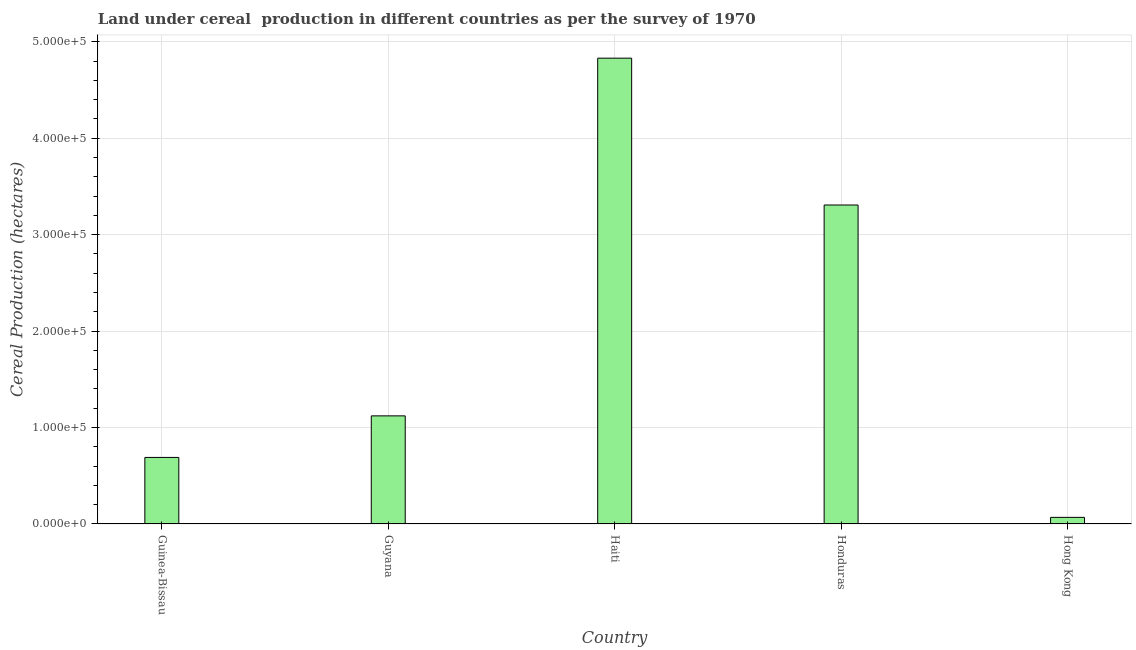Does the graph contain any zero values?
Your answer should be compact. No. What is the title of the graph?
Offer a terse response. Land under cereal  production in different countries as per the survey of 1970. What is the label or title of the X-axis?
Offer a very short reply. Country. What is the label or title of the Y-axis?
Your response must be concise. Cereal Production (hectares). What is the land under cereal production in Guinea-Bissau?
Offer a terse response. 6.90e+04. Across all countries, what is the maximum land under cereal production?
Provide a short and direct response. 4.83e+05. Across all countries, what is the minimum land under cereal production?
Provide a succinct answer. 6861. In which country was the land under cereal production maximum?
Provide a short and direct response. Haiti. In which country was the land under cereal production minimum?
Provide a succinct answer. Hong Kong. What is the sum of the land under cereal production?
Keep it short and to the point. 1.00e+06. What is the difference between the land under cereal production in Guinea-Bissau and Guyana?
Your answer should be compact. -4.31e+04. What is the average land under cereal production per country?
Ensure brevity in your answer.  2.00e+05. What is the median land under cereal production?
Provide a succinct answer. 1.12e+05. In how many countries, is the land under cereal production greater than 260000 hectares?
Offer a very short reply. 2. What is the ratio of the land under cereal production in Guinea-Bissau to that in Honduras?
Provide a short and direct response. 0.21. Is the difference between the land under cereal production in Guyana and Honduras greater than the difference between any two countries?
Give a very brief answer. No. What is the difference between the highest and the second highest land under cereal production?
Provide a short and direct response. 1.52e+05. Is the sum of the land under cereal production in Guyana and Haiti greater than the maximum land under cereal production across all countries?
Provide a short and direct response. Yes. What is the difference between the highest and the lowest land under cereal production?
Make the answer very short. 4.76e+05. How many bars are there?
Ensure brevity in your answer.  5. What is the Cereal Production (hectares) in Guinea-Bissau?
Provide a succinct answer. 6.90e+04. What is the Cereal Production (hectares) in Guyana?
Provide a short and direct response. 1.12e+05. What is the Cereal Production (hectares) of Haiti?
Give a very brief answer. 4.83e+05. What is the Cereal Production (hectares) of Honduras?
Make the answer very short. 3.31e+05. What is the Cereal Production (hectares) in Hong Kong?
Provide a succinct answer. 6861. What is the difference between the Cereal Production (hectares) in Guinea-Bissau and Guyana?
Ensure brevity in your answer.  -4.31e+04. What is the difference between the Cereal Production (hectares) in Guinea-Bissau and Haiti?
Ensure brevity in your answer.  -4.14e+05. What is the difference between the Cereal Production (hectares) in Guinea-Bissau and Honduras?
Provide a short and direct response. -2.62e+05. What is the difference between the Cereal Production (hectares) in Guinea-Bissau and Hong Kong?
Your answer should be very brief. 6.21e+04. What is the difference between the Cereal Production (hectares) in Guyana and Haiti?
Your answer should be compact. -3.71e+05. What is the difference between the Cereal Production (hectares) in Guyana and Honduras?
Make the answer very short. -2.19e+05. What is the difference between the Cereal Production (hectares) in Guyana and Hong Kong?
Offer a very short reply. 1.05e+05. What is the difference between the Cereal Production (hectares) in Haiti and Honduras?
Give a very brief answer. 1.52e+05. What is the difference between the Cereal Production (hectares) in Haiti and Hong Kong?
Ensure brevity in your answer.  4.76e+05. What is the difference between the Cereal Production (hectares) in Honduras and Hong Kong?
Your answer should be compact. 3.24e+05. What is the ratio of the Cereal Production (hectares) in Guinea-Bissau to that in Guyana?
Your answer should be compact. 0.62. What is the ratio of the Cereal Production (hectares) in Guinea-Bissau to that in Haiti?
Your answer should be very brief. 0.14. What is the ratio of the Cereal Production (hectares) in Guinea-Bissau to that in Honduras?
Your answer should be compact. 0.21. What is the ratio of the Cereal Production (hectares) in Guinea-Bissau to that in Hong Kong?
Keep it short and to the point. 10.06. What is the ratio of the Cereal Production (hectares) in Guyana to that in Haiti?
Ensure brevity in your answer.  0.23. What is the ratio of the Cereal Production (hectares) in Guyana to that in Honduras?
Keep it short and to the point. 0.34. What is the ratio of the Cereal Production (hectares) in Guyana to that in Hong Kong?
Give a very brief answer. 16.34. What is the ratio of the Cereal Production (hectares) in Haiti to that in Honduras?
Ensure brevity in your answer.  1.46. What is the ratio of the Cereal Production (hectares) in Haiti to that in Hong Kong?
Your response must be concise. 70.4. What is the ratio of the Cereal Production (hectares) in Honduras to that in Hong Kong?
Offer a very short reply. 48.21. 